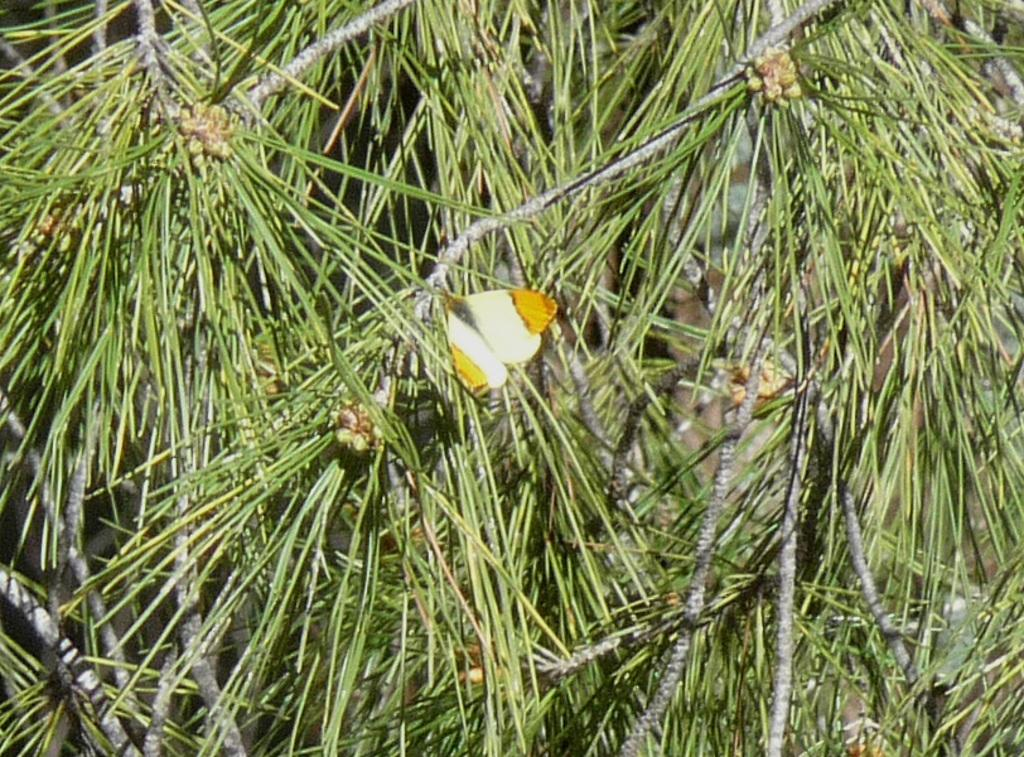What type of animal can be seen in the image? There is a butterfly in the image. What other living organisms are present in the image? There are plants in the image. What type of leather can be seen in the image? There is no leather present in the image; it features a butterfly and plants. 